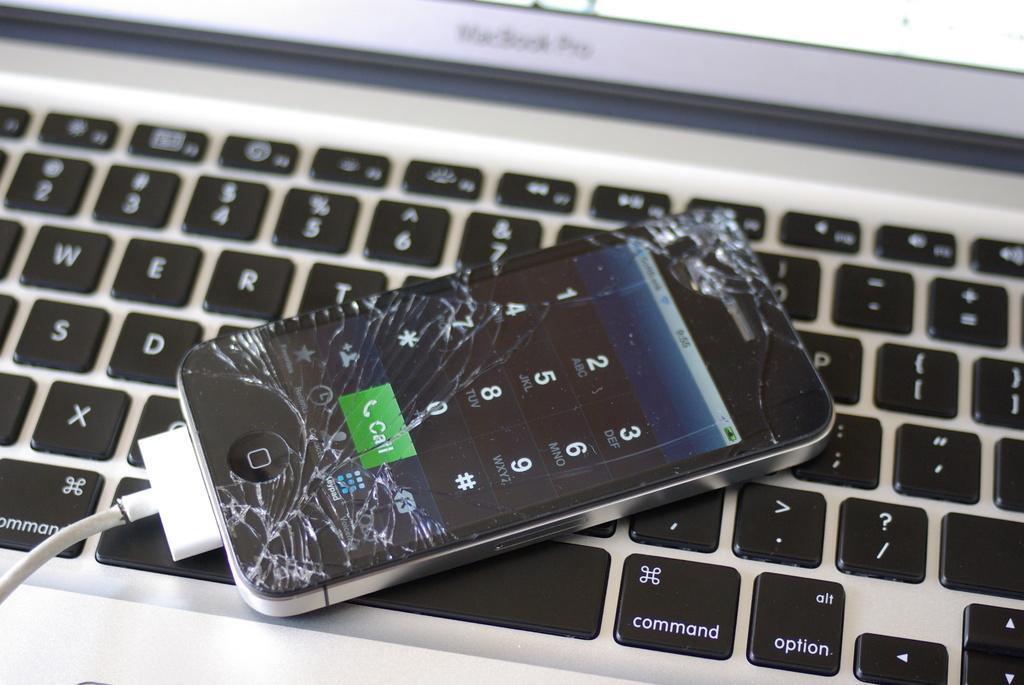<image>
Offer a succinct explanation of the picture presented. A shattered cell phone lays on the keyboard of a Mac Book Pro. 